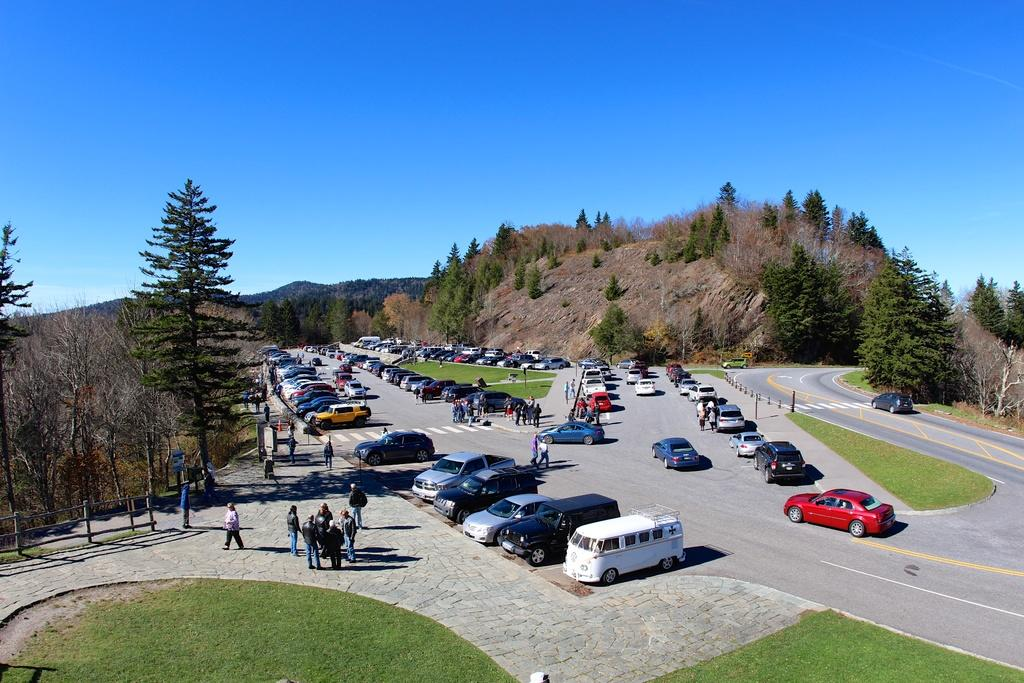What is happening on the road in the image? There are vehicles on a road in the image. Are there any people present in the image? Yes, there are people standing in the image. What can be seen in the distance in the image? There are trees, mountains, and the sky visible in the background of the image. What type of impulse can be seen affecting the vehicles on the road in the image? There is no indication of any impulse affecting the vehicles in the image; they are simply driving on the road. Can you tell me where the stove is located in the image? There is no stove present in the image. 